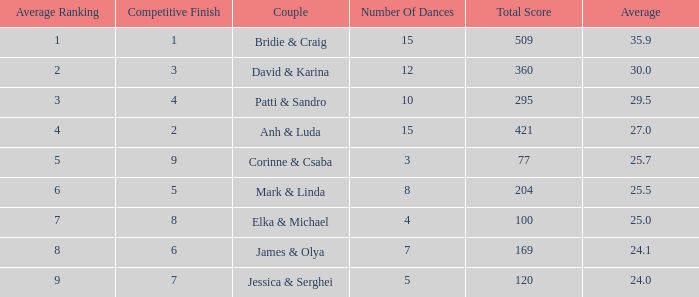Which couple has 295 as a total score? Patti & Sandro. 